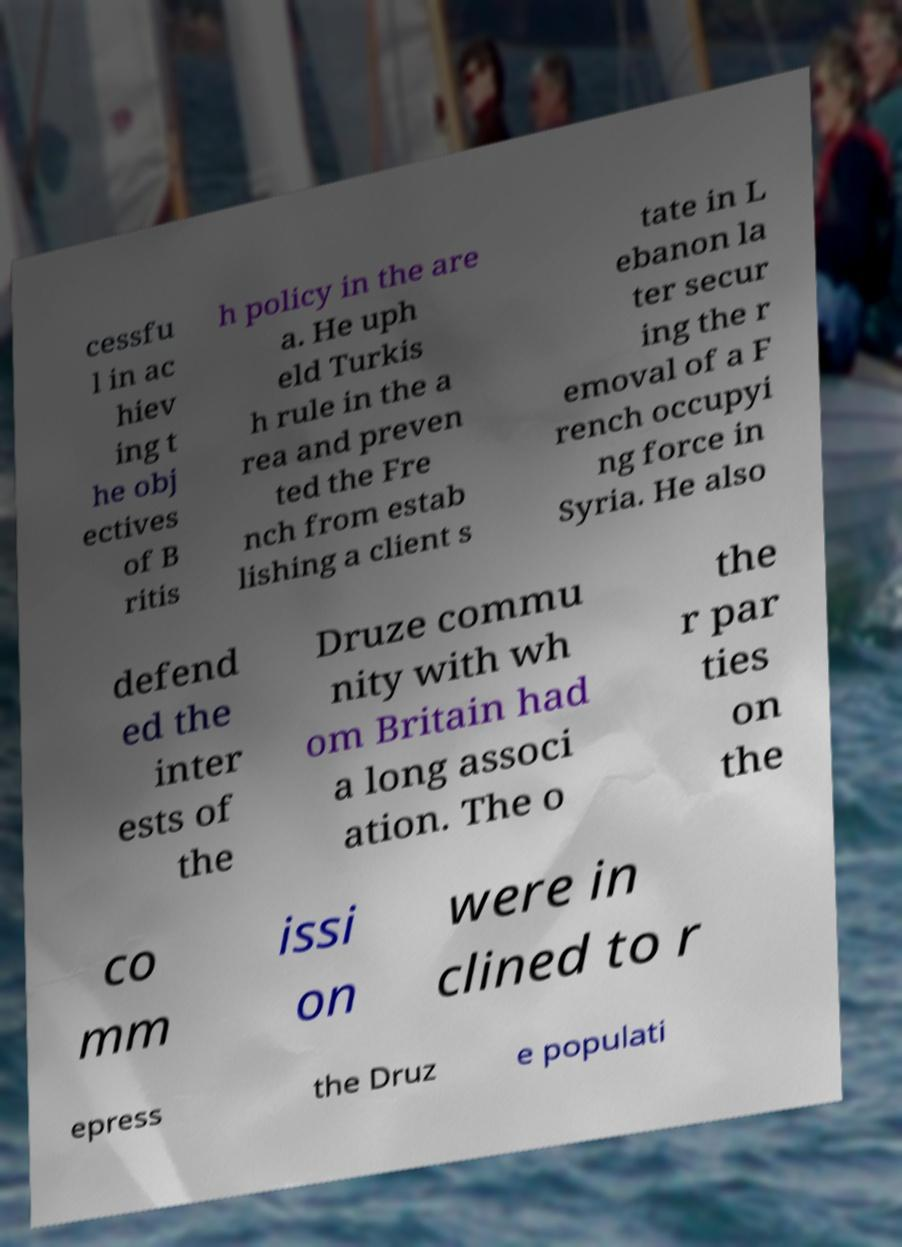What messages or text are displayed in this image? I need them in a readable, typed format. cessfu l in ac hiev ing t he obj ectives of B ritis h policy in the are a. He uph eld Turkis h rule in the a rea and preven ted the Fre nch from estab lishing a client s tate in L ebanon la ter secur ing the r emoval of a F rench occupyi ng force in Syria. He also defend ed the inter ests of the Druze commu nity with wh om Britain had a long associ ation. The o the r par ties on the co mm issi on were in clined to r epress the Druz e populati 